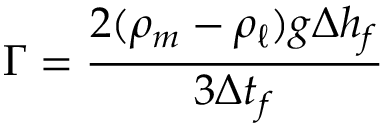Convert formula to latex. <formula><loc_0><loc_0><loc_500><loc_500>\Gamma = \frac { 2 ( \rho _ { m } - \rho _ { \ell } ) g \Delta h _ { f } } { 3 \Delta t _ { f } }</formula> 